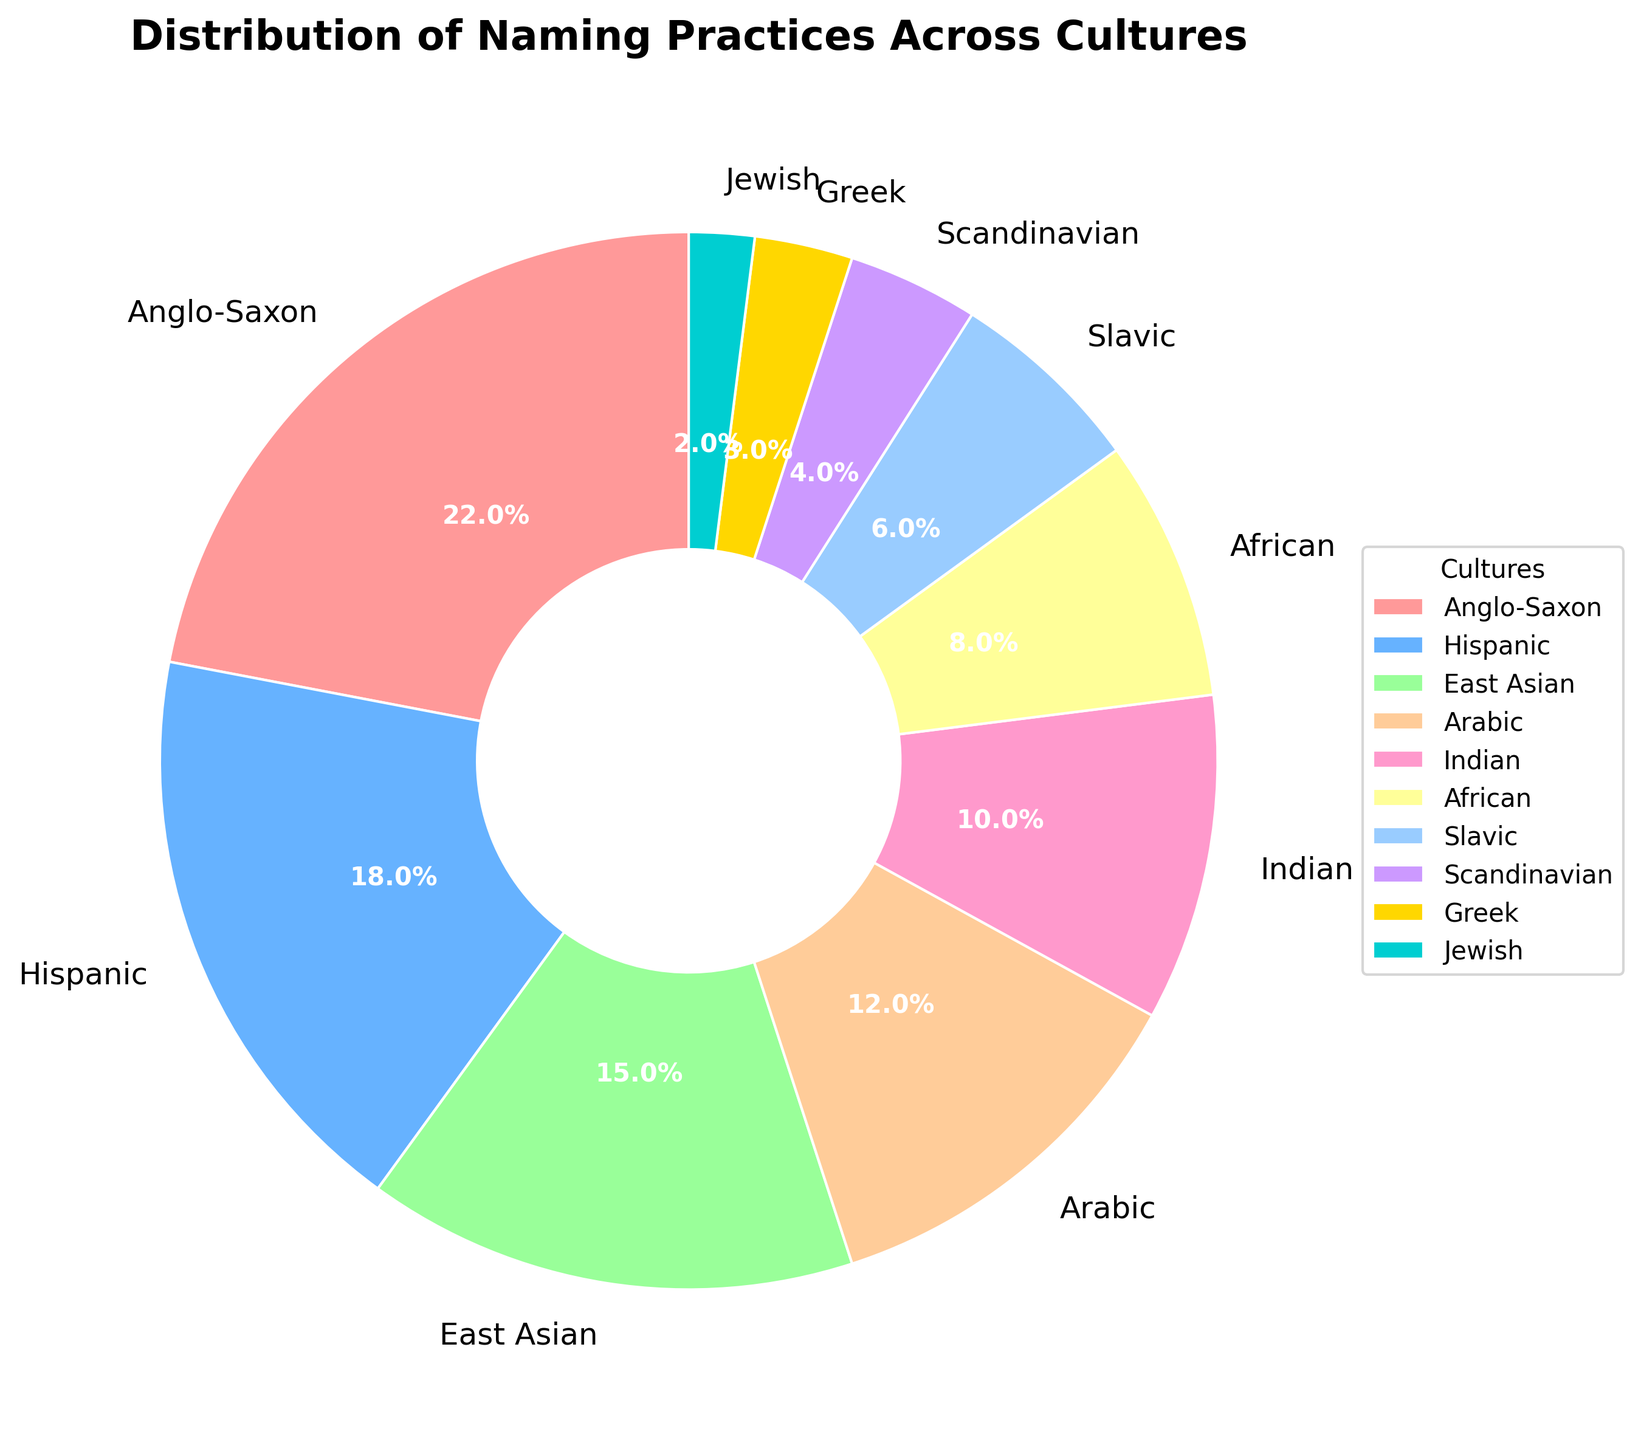What percentage of the naming practices comes from African culture? Locate the African segment in the pie chart, which is labeled. Visually, the chart shows that African culture comprises 8% of the naming practices.
Answer: 8% Which cultures have a naming percentage greater than 10%? Identify all segments in the pie chart with a percentage label of more than 10%. The cultures meeting this criterion are Anglo-Saxon, Hispanic, East Asian, and Arabic.
Answer: Anglo-Saxon, Hispanic, East Asian, Arabic What is the combined percentage of East Asian and Indian naming practices? Locate the East Asian and Indian segments in the pie chart, which show 15% and 10% respectively. Adding these values, 15 + 10 = 25%.
Answer: 25% Which culture has the smallest percentage of naming practices and what is this percentage? Identify the segment with the smallest percentage in the pie chart, which is Jewish, showing 2%.
Answer: Jewish, 2% Which two adjacent cultures in the pie chart together sum up to 30% of the naming practices, and what are their cultural names? Look for two adjacent segments in the pie chart where their combined values equal 30%. The Anglo-Saxon segment (22%) and the Hispanic segment (18%) sum up to 22 + 18 = 40%, which is the closest to 30%. However, none of the cultures add up exactly to 30%.
Answer: No exact combination How does the naming practice percentage of Slavic culture compare to Scandinavian culture? Identify the segments for Slavic and Scandinavian cultures in the pie chart, which are labeled 6% and 4% respectively. Comparing these, Slavic culture has a higher percentage than Scandinavian culture.
Answer: Slavic > What is the percentage difference between Arabic and Indian naming practices? Identify the Arabic and Indian segments in the pie chart, which show 12% and 10% respectively. Calculate the difference, 12% - 10% = 2%.
Answer: 2% Which culture is represented by the color gold in the pie chart, and what is its percentage? Locate the segment labeled "Jewish" and note its color (gold). The segment shows a percentage of 2%.
Answer: Jewish, 2% What is the total percentage of naming practices for cultures contributing less than or equal to 6%? Sum the percentages of cultures with 6% or less: Slavic (6%), Scandinavian (4%), Greek (3%), and Jewish (2%). Thus, 6 + 4 + 3 + 2 = 15%.
Answer: 15% Identify the culture represented by the light blue segment and state its percentage. Locate the segment colored light blue and verify its label, which is Hispanic, showing 18%.
Answer: Hispanic, 18% 